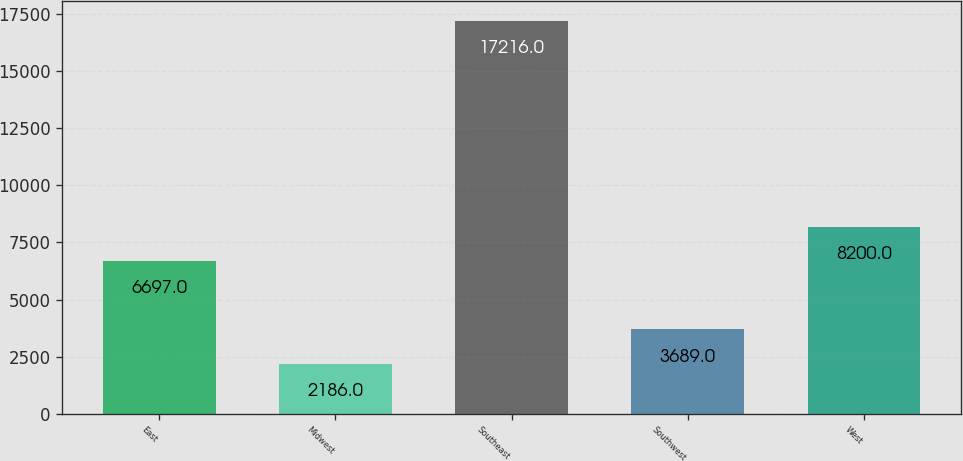<chart> <loc_0><loc_0><loc_500><loc_500><bar_chart><fcel>East<fcel>Midwest<fcel>Southeast<fcel>Southwest<fcel>West<nl><fcel>6697<fcel>2186<fcel>17216<fcel>3689<fcel>8200<nl></chart> 